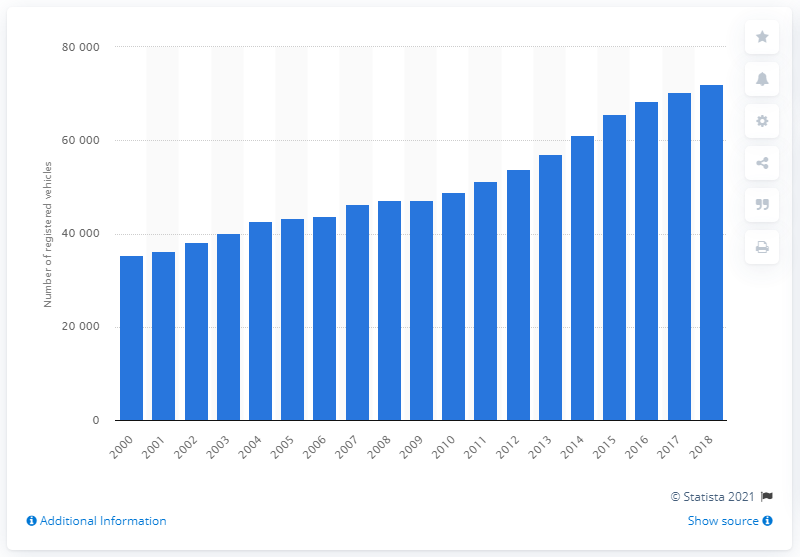Indicate a few pertinent items in this graphic. In 2000, there were 35,295 registered vehicles in Great Britain. In 2018, a total of 72,037 Toyota Hilux light goods vehicles were registered in Great Britain. 